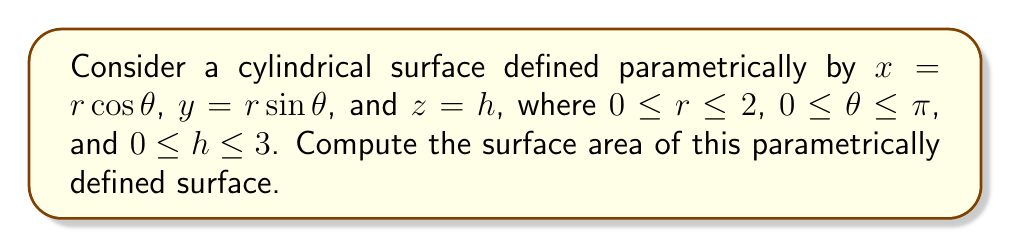Could you help me with this problem? To compute the surface area of a parametrically defined surface, we use the formula:

$$ A = \iint_D \left|\frac{\partial \mathbf{r}}{\partial u} \times \frac{\partial \mathbf{r}}{\partial v}\right| \, du \, dv $$

Where $\mathbf{r}(u,v)$ is the parametric representation of the surface.

Step 1: Identify the parameters and their ranges.
$u = r$, $v = \theta$, and $h$ is a function of $r$ and $\theta$.
$0 \leq r \leq 2$, $0 \leq \theta \leq \pi$, and $0 \leq h \leq 3$

Step 2: Calculate partial derivatives.
$\frac{\partial \mathbf{r}}{\partial r} = (\cos\theta, \sin\theta, 0)$
$\frac{\partial \mathbf{r}}{\partial \theta} = (-r\sin\theta, r\cos\theta, 0)$

Step 3: Compute the cross product.
$\frac{\partial \mathbf{r}}{\partial r} \times \frac{\partial \mathbf{r}}{\partial \theta} = (0, 0, r)$

Step 4: Calculate the magnitude of the cross product.
$\left|\frac{\partial \mathbf{r}}{\partial r} \times \frac{\partial \mathbf{r}}{\partial \theta}\right| = r$

Step 5: Set up the double integral.
$$ A = \int_0^\pi \int_0^2 r \, dr \, d\theta $$

Step 6: Evaluate the inner integral.
$$ A = \int_0^\pi \left[\frac{r^2}{2}\right]_0^2 \, d\theta = \int_0^\pi 2 \, d\theta $$

Step 7: Evaluate the outer integral.
$$ A = [2\theta]_0^\pi = 2\pi $$

Therefore, the surface area of the cylindrical surface is $2\pi$ square units.
Answer: $2\pi$ square units 